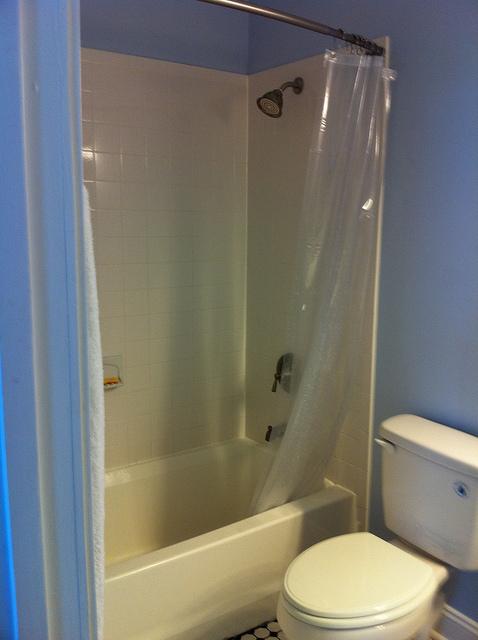What color are the walls?
Short answer required. Blue. What room is this?
Keep it brief. Bathroom. Can someone sit on the toilet to wash their feet?
Be succinct. Yes. 